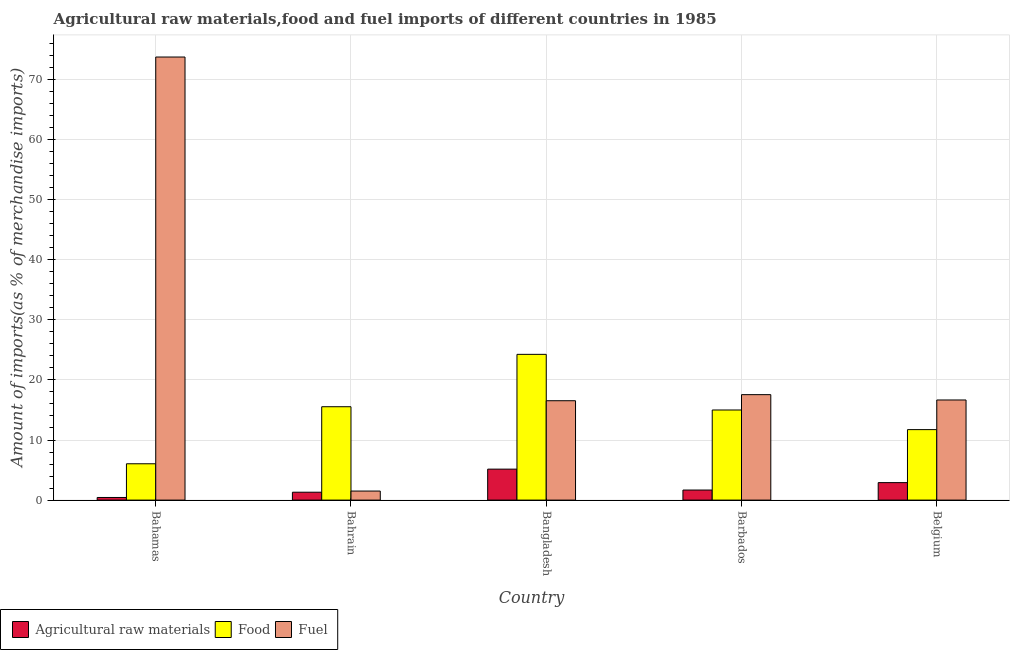Are the number of bars on each tick of the X-axis equal?
Provide a short and direct response. Yes. How many bars are there on the 2nd tick from the left?
Offer a terse response. 3. What is the percentage of food imports in Belgium?
Offer a very short reply. 11.73. Across all countries, what is the maximum percentage of fuel imports?
Your answer should be very brief. 73.72. Across all countries, what is the minimum percentage of raw materials imports?
Provide a succinct answer. 0.44. In which country was the percentage of food imports maximum?
Give a very brief answer. Bangladesh. In which country was the percentage of food imports minimum?
Offer a very short reply. Bahamas. What is the total percentage of fuel imports in the graph?
Offer a terse response. 125.97. What is the difference between the percentage of fuel imports in Bahamas and that in Belgium?
Ensure brevity in your answer.  57.06. What is the difference between the percentage of fuel imports in Bahamas and the percentage of food imports in Belgium?
Offer a very short reply. 61.99. What is the average percentage of fuel imports per country?
Your answer should be compact. 25.19. What is the difference between the percentage of food imports and percentage of fuel imports in Bahamas?
Provide a short and direct response. -67.68. What is the ratio of the percentage of fuel imports in Bahrain to that in Belgium?
Keep it short and to the point. 0.09. Is the difference between the percentage of food imports in Bahrain and Barbados greater than the difference between the percentage of raw materials imports in Bahrain and Barbados?
Your answer should be very brief. Yes. What is the difference between the highest and the second highest percentage of raw materials imports?
Give a very brief answer. 2.24. What is the difference between the highest and the lowest percentage of food imports?
Make the answer very short. 18.21. In how many countries, is the percentage of food imports greater than the average percentage of food imports taken over all countries?
Give a very brief answer. 3. Is the sum of the percentage of raw materials imports in Bahamas and Belgium greater than the maximum percentage of fuel imports across all countries?
Your response must be concise. No. What does the 2nd bar from the left in Bahrain represents?
Offer a very short reply. Food. What does the 3rd bar from the right in Bahamas represents?
Keep it short and to the point. Agricultural raw materials. Are all the bars in the graph horizontal?
Make the answer very short. No. How many countries are there in the graph?
Your answer should be very brief. 5. Does the graph contain any zero values?
Make the answer very short. No. Does the graph contain grids?
Provide a succinct answer. Yes. How are the legend labels stacked?
Give a very brief answer. Horizontal. What is the title of the graph?
Provide a succinct answer. Agricultural raw materials,food and fuel imports of different countries in 1985. What is the label or title of the X-axis?
Offer a very short reply. Country. What is the label or title of the Y-axis?
Make the answer very short. Amount of imports(as % of merchandise imports). What is the Amount of imports(as % of merchandise imports) of Agricultural raw materials in Bahamas?
Give a very brief answer. 0.44. What is the Amount of imports(as % of merchandise imports) of Food in Bahamas?
Your answer should be compact. 6.05. What is the Amount of imports(as % of merchandise imports) of Fuel in Bahamas?
Your response must be concise. 73.72. What is the Amount of imports(as % of merchandise imports) in Agricultural raw materials in Bahrain?
Offer a terse response. 1.31. What is the Amount of imports(as % of merchandise imports) of Food in Bahrain?
Your answer should be compact. 15.54. What is the Amount of imports(as % of merchandise imports) in Fuel in Bahrain?
Offer a very short reply. 1.51. What is the Amount of imports(as % of merchandise imports) in Agricultural raw materials in Bangladesh?
Your answer should be very brief. 5.15. What is the Amount of imports(as % of merchandise imports) in Food in Bangladesh?
Your answer should be very brief. 24.25. What is the Amount of imports(as % of merchandise imports) of Fuel in Bangladesh?
Make the answer very short. 16.54. What is the Amount of imports(as % of merchandise imports) in Agricultural raw materials in Barbados?
Offer a very short reply. 1.67. What is the Amount of imports(as % of merchandise imports) in Food in Barbados?
Make the answer very short. 14.99. What is the Amount of imports(as % of merchandise imports) in Fuel in Barbados?
Provide a short and direct response. 17.55. What is the Amount of imports(as % of merchandise imports) of Agricultural raw materials in Belgium?
Your answer should be compact. 2.91. What is the Amount of imports(as % of merchandise imports) of Food in Belgium?
Keep it short and to the point. 11.73. What is the Amount of imports(as % of merchandise imports) of Fuel in Belgium?
Your answer should be very brief. 16.66. Across all countries, what is the maximum Amount of imports(as % of merchandise imports) of Agricultural raw materials?
Ensure brevity in your answer.  5.15. Across all countries, what is the maximum Amount of imports(as % of merchandise imports) of Food?
Keep it short and to the point. 24.25. Across all countries, what is the maximum Amount of imports(as % of merchandise imports) of Fuel?
Keep it short and to the point. 73.72. Across all countries, what is the minimum Amount of imports(as % of merchandise imports) of Agricultural raw materials?
Provide a short and direct response. 0.44. Across all countries, what is the minimum Amount of imports(as % of merchandise imports) of Food?
Offer a terse response. 6.05. Across all countries, what is the minimum Amount of imports(as % of merchandise imports) in Fuel?
Your answer should be very brief. 1.51. What is the total Amount of imports(as % of merchandise imports) in Agricultural raw materials in the graph?
Make the answer very short. 11.49. What is the total Amount of imports(as % of merchandise imports) in Food in the graph?
Your answer should be very brief. 72.56. What is the total Amount of imports(as % of merchandise imports) of Fuel in the graph?
Make the answer very short. 125.97. What is the difference between the Amount of imports(as % of merchandise imports) of Agricultural raw materials in Bahamas and that in Bahrain?
Offer a terse response. -0.88. What is the difference between the Amount of imports(as % of merchandise imports) in Food in Bahamas and that in Bahrain?
Make the answer very short. -9.49. What is the difference between the Amount of imports(as % of merchandise imports) of Fuel in Bahamas and that in Bahrain?
Make the answer very short. 72.22. What is the difference between the Amount of imports(as % of merchandise imports) of Agricultural raw materials in Bahamas and that in Bangladesh?
Make the answer very short. -4.72. What is the difference between the Amount of imports(as % of merchandise imports) in Food in Bahamas and that in Bangladesh?
Offer a terse response. -18.21. What is the difference between the Amount of imports(as % of merchandise imports) in Fuel in Bahamas and that in Bangladesh?
Give a very brief answer. 57.19. What is the difference between the Amount of imports(as % of merchandise imports) in Agricultural raw materials in Bahamas and that in Barbados?
Offer a terse response. -1.24. What is the difference between the Amount of imports(as % of merchandise imports) of Food in Bahamas and that in Barbados?
Give a very brief answer. -8.95. What is the difference between the Amount of imports(as % of merchandise imports) in Fuel in Bahamas and that in Barbados?
Offer a terse response. 56.18. What is the difference between the Amount of imports(as % of merchandise imports) in Agricultural raw materials in Bahamas and that in Belgium?
Your answer should be very brief. -2.47. What is the difference between the Amount of imports(as % of merchandise imports) in Food in Bahamas and that in Belgium?
Offer a terse response. -5.68. What is the difference between the Amount of imports(as % of merchandise imports) in Fuel in Bahamas and that in Belgium?
Your answer should be very brief. 57.06. What is the difference between the Amount of imports(as % of merchandise imports) in Agricultural raw materials in Bahrain and that in Bangladesh?
Offer a terse response. -3.84. What is the difference between the Amount of imports(as % of merchandise imports) of Food in Bahrain and that in Bangladesh?
Your response must be concise. -8.72. What is the difference between the Amount of imports(as % of merchandise imports) of Fuel in Bahrain and that in Bangladesh?
Your response must be concise. -15.03. What is the difference between the Amount of imports(as % of merchandise imports) in Agricultural raw materials in Bahrain and that in Barbados?
Your response must be concise. -0.36. What is the difference between the Amount of imports(as % of merchandise imports) of Food in Bahrain and that in Barbados?
Make the answer very short. 0.54. What is the difference between the Amount of imports(as % of merchandise imports) in Fuel in Bahrain and that in Barbados?
Your response must be concise. -16.04. What is the difference between the Amount of imports(as % of merchandise imports) of Agricultural raw materials in Bahrain and that in Belgium?
Keep it short and to the point. -1.6. What is the difference between the Amount of imports(as % of merchandise imports) of Food in Bahrain and that in Belgium?
Offer a very short reply. 3.81. What is the difference between the Amount of imports(as % of merchandise imports) of Fuel in Bahrain and that in Belgium?
Your response must be concise. -15.15. What is the difference between the Amount of imports(as % of merchandise imports) in Agricultural raw materials in Bangladesh and that in Barbados?
Your answer should be compact. 3.48. What is the difference between the Amount of imports(as % of merchandise imports) of Food in Bangladesh and that in Barbados?
Your answer should be compact. 9.26. What is the difference between the Amount of imports(as % of merchandise imports) of Fuel in Bangladesh and that in Barbados?
Provide a succinct answer. -1.01. What is the difference between the Amount of imports(as % of merchandise imports) in Agricultural raw materials in Bangladesh and that in Belgium?
Provide a succinct answer. 2.24. What is the difference between the Amount of imports(as % of merchandise imports) in Food in Bangladesh and that in Belgium?
Make the answer very short. 12.52. What is the difference between the Amount of imports(as % of merchandise imports) in Fuel in Bangladesh and that in Belgium?
Provide a short and direct response. -0.13. What is the difference between the Amount of imports(as % of merchandise imports) of Agricultural raw materials in Barbados and that in Belgium?
Provide a succinct answer. -1.24. What is the difference between the Amount of imports(as % of merchandise imports) of Food in Barbados and that in Belgium?
Offer a very short reply. 3.26. What is the difference between the Amount of imports(as % of merchandise imports) of Fuel in Barbados and that in Belgium?
Your answer should be compact. 0.89. What is the difference between the Amount of imports(as % of merchandise imports) in Agricultural raw materials in Bahamas and the Amount of imports(as % of merchandise imports) in Food in Bahrain?
Your response must be concise. -15.1. What is the difference between the Amount of imports(as % of merchandise imports) of Agricultural raw materials in Bahamas and the Amount of imports(as % of merchandise imports) of Fuel in Bahrain?
Offer a very short reply. -1.07. What is the difference between the Amount of imports(as % of merchandise imports) of Food in Bahamas and the Amount of imports(as % of merchandise imports) of Fuel in Bahrain?
Offer a very short reply. 4.54. What is the difference between the Amount of imports(as % of merchandise imports) of Agricultural raw materials in Bahamas and the Amount of imports(as % of merchandise imports) of Food in Bangladesh?
Ensure brevity in your answer.  -23.82. What is the difference between the Amount of imports(as % of merchandise imports) of Agricultural raw materials in Bahamas and the Amount of imports(as % of merchandise imports) of Fuel in Bangladesh?
Your response must be concise. -16.1. What is the difference between the Amount of imports(as % of merchandise imports) in Food in Bahamas and the Amount of imports(as % of merchandise imports) in Fuel in Bangladesh?
Give a very brief answer. -10.49. What is the difference between the Amount of imports(as % of merchandise imports) in Agricultural raw materials in Bahamas and the Amount of imports(as % of merchandise imports) in Food in Barbados?
Give a very brief answer. -14.56. What is the difference between the Amount of imports(as % of merchandise imports) in Agricultural raw materials in Bahamas and the Amount of imports(as % of merchandise imports) in Fuel in Barbados?
Offer a terse response. -17.11. What is the difference between the Amount of imports(as % of merchandise imports) in Food in Bahamas and the Amount of imports(as % of merchandise imports) in Fuel in Barbados?
Give a very brief answer. -11.5. What is the difference between the Amount of imports(as % of merchandise imports) in Agricultural raw materials in Bahamas and the Amount of imports(as % of merchandise imports) in Food in Belgium?
Provide a short and direct response. -11.29. What is the difference between the Amount of imports(as % of merchandise imports) in Agricultural raw materials in Bahamas and the Amount of imports(as % of merchandise imports) in Fuel in Belgium?
Your response must be concise. -16.23. What is the difference between the Amount of imports(as % of merchandise imports) in Food in Bahamas and the Amount of imports(as % of merchandise imports) in Fuel in Belgium?
Ensure brevity in your answer.  -10.62. What is the difference between the Amount of imports(as % of merchandise imports) in Agricultural raw materials in Bahrain and the Amount of imports(as % of merchandise imports) in Food in Bangladesh?
Offer a very short reply. -22.94. What is the difference between the Amount of imports(as % of merchandise imports) of Agricultural raw materials in Bahrain and the Amount of imports(as % of merchandise imports) of Fuel in Bangladesh?
Offer a very short reply. -15.22. What is the difference between the Amount of imports(as % of merchandise imports) in Food in Bahrain and the Amount of imports(as % of merchandise imports) in Fuel in Bangladesh?
Offer a terse response. -1. What is the difference between the Amount of imports(as % of merchandise imports) in Agricultural raw materials in Bahrain and the Amount of imports(as % of merchandise imports) in Food in Barbados?
Make the answer very short. -13.68. What is the difference between the Amount of imports(as % of merchandise imports) in Agricultural raw materials in Bahrain and the Amount of imports(as % of merchandise imports) in Fuel in Barbados?
Offer a very short reply. -16.23. What is the difference between the Amount of imports(as % of merchandise imports) of Food in Bahrain and the Amount of imports(as % of merchandise imports) of Fuel in Barbados?
Offer a very short reply. -2.01. What is the difference between the Amount of imports(as % of merchandise imports) in Agricultural raw materials in Bahrain and the Amount of imports(as % of merchandise imports) in Food in Belgium?
Offer a terse response. -10.42. What is the difference between the Amount of imports(as % of merchandise imports) of Agricultural raw materials in Bahrain and the Amount of imports(as % of merchandise imports) of Fuel in Belgium?
Give a very brief answer. -15.35. What is the difference between the Amount of imports(as % of merchandise imports) of Food in Bahrain and the Amount of imports(as % of merchandise imports) of Fuel in Belgium?
Your answer should be very brief. -1.12. What is the difference between the Amount of imports(as % of merchandise imports) in Agricultural raw materials in Bangladesh and the Amount of imports(as % of merchandise imports) in Food in Barbados?
Make the answer very short. -9.84. What is the difference between the Amount of imports(as % of merchandise imports) of Agricultural raw materials in Bangladesh and the Amount of imports(as % of merchandise imports) of Fuel in Barbados?
Offer a terse response. -12.39. What is the difference between the Amount of imports(as % of merchandise imports) of Food in Bangladesh and the Amount of imports(as % of merchandise imports) of Fuel in Barbados?
Keep it short and to the point. 6.71. What is the difference between the Amount of imports(as % of merchandise imports) of Agricultural raw materials in Bangladesh and the Amount of imports(as % of merchandise imports) of Food in Belgium?
Offer a very short reply. -6.58. What is the difference between the Amount of imports(as % of merchandise imports) of Agricultural raw materials in Bangladesh and the Amount of imports(as % of merchandise imports) of Fuel in Belgium?
Provide a succinct answer. -11.51. What is the difference between the Amount of imports(as % of merchandise imports) in Food in Bangladesh and the Amount of imports(as % of merchandise imports) in Fuel in Belgium?
Your answer should be very brief. 7.59. What is the difference between the Amount of imports(as % of merchandise imports) in Agricultural raw materials in Barbados and the Amount of imports(as % of merchandise imports) in Food in Belgium?
Keep it short and to the point. -10.05. What is the difference between the Amount of imports(as % of merchandise imports) of Agricultural raw materials in Barbados and the Amount of imports(as % of merchandise imports) of Fuel in Belgium?
Your response must be concise. -14.99. What is the difference between the Amount of imports(as % of merchandise imports) in Food in Barbados and the Amount of imports(as % of merchandise imports) in Fuel in Belgium?
Offer a terse response. -1.67. What is the average Amount of imports(as % of merchandise imports) in Agricultural raw materials per country?
Give a very brief answer. 2.3. What is the average Amount of imports(as % of merchandise imports) in Food per country?
Provide a short and direct response. 14.51. What is the average Amount of imports(as % of merchandise imports) in Fuel per country?
Your answer should be compact. 25.19. What is the difference between the Amount of imports(as % of merchandise imports) of Agricultural raw materials and Amount of imports(as % of merchandise imports) of Food in Bahamas?
Offer a terse response. -5.61. What is the difference between the Amount of imports(as % of merchandise imports) of Agricultural raw materials and Amount of imports(as % of merchandise imports) of Fuel in Bahamas?
Provide a short and direct response. -73.29. What is the difference between the Amount of imports(as % of merchandise imports) in Food and Amount of imports(as % of merchandise imports) in Fuel in Bahamas?
Your response must be concise. -67.68. What is the difference between the Amount of imports(as % of merchandise imports) in Agricultural raw materials and Amount of imports(as % of merchandise imports) in Food in Bahrain?
Provide a succinct answer. -14.22. What is the difference between the Amount of imports(as % of merchandise imports) in Agricultural raw materials and Amount of imports(as % of merchandise imports) in Fuel in Bahrain?
Give a very brief answer. -0.19. What is the difference between the Amount of imports(as % of merchandise imports) of Food and Amount of imports(as % of merchandise imports) of Fuel in Bahrain?
Offer a terse response. 14.03. What is the difference between the Amount of imports(as % of merchandise imports) in Agricultural raw materials and Amount of imports(as % of merchandise imports) in Food in Bangladesh?
Give a very brief answer. -19.1. What is the difference between the Amount of imports(as % of merchandise imports) of Agricultural raw materials and Amount of imports(as % of merchandise imports) of Fuel in Bangladesh?
Keep it short and to the point. -11.38. What is the difference between the Amount of imports(as % of merchandise imports) in Food and Amount of imports(as % of merchandise imports) in Fuel in Bangladesh?
Provide a short and direct response. 7.72. What is the difference between the Amount of imports(as % of merchandise imports) in Agricultural raw materials and Amount of imports(as % of merchandise imports) in Food in Barbados?
Offer a very short reply. -13.32. What is the difference between the Amount of imports(as % of merchandise imports) in Agricultural raw materials and Amount of imports(as % of merchandise imports) in Fuel in Barbados?
Provide a short and direct response. -15.87. What is the difference between the Amount of imports(as % of merchandise imports) in Food and Amount of imports(as % of merchandise imports) in Fuel in Barbados?
Provide a succinct answer. -2.55. What is the difference between the Amount of imports(as % of merchandise imports) of Agricultural raw materials and Amount of imports(as % of merchandise imports) of Food in Belgium?
Offer a terse response. -8.82. What is the difference between the Amount of imports(as % of merchandise imports) of Agricultural raw materials and Amount of imports(as % of merchandise imports) of Fuel in Belgium?
Make the answer very short. -13.75. What is the difference between the Amount of imports(as % of merchandise imports) in Food and Amount of imports(as % of merchandise imports) in Fuel in Belgium?
Offer a very short reply. -4.93. What is the ratio of the Amount of imports(as % of merchandise imports) in Agricultural raw materials in Bahamas to that in Bahrain?
Offer a very short reply. 0.33. What is the ratio of the Amount of imports(as % of merchandise imports) of Food in Bahamas to that in Bahrain?
Your answer should be compact. 0.39. What is the ratio of the Amount of imports(as % of merchandise imports) of Fuel in Bahamas to that in Bahrain?
Your response must be concise. 48.95. What is the ratio of the Amount of imports(as % of merchandise imports) of Agricultural raw materials in Bahamas to that in Bangladesh?
Give a very brief answer. 0.08. What is the ratio of the Amount of imports(as % of merchandise imports) of Food in Bahamas to that in Bangladesh?
Your answer should be very brief. 0.25. What is the ratio of the Amount of imports(as % of merchandise imports) of Fuel in Bahamas to that in Bangladesh?
Give a very brief answer. 4.46. What is the ratio of the Amount of imports(as % of merchandise imports) in Agricultural raw materials in Bahamas to that in Barbados?
Give a very brief answer. 0.26. What is the ratio of the Amount of imports(as % of merchandise imports) in Food in Bahamas to that in Barbados?
Keep it short and to the point. 0.4. What is the ratio of the Amount of imports(as % of merchandise imports) of Fuel in Bahamas to that in Barbados?
Offer a very short reply. 4.2. What is the ratio of the Amount of imports(as % of merchandise imports) of Agricultural raw materials in Bahamas to that in Belgium?
Offer a very short reply. 0.15. What is the ratio of the Amount of imports(as % of merchandise imports) of Food in Bahamas to that in Belgium?
Offer a terse response. 0.52. What is the ratio of the Amount of imports(as % of merchandise imports) in Fuel in Bahamas to that in Belgium?
Your response must be concise. 4.42. What is the ratio of the Amount of imports(as % of merchandise imports) in Agricultural raw materials in Bahrain to that in Bangladesh?
Offer a terse response. 0.26. What is the ratio of the Amount of imports(as % of merchandise imports) of Food in Bahrain to that in Bangladesh?
Provide a succinct answer. 0.64. What is the ratio of the Amount of imports(as % of merchandise imports) of Fuel in Bahrain to that in Bangladesh?
Make the answer very short. 0.09. What is the ratio of the Amount of imports(as % of merchandise imports) in Agricultural raw materials in Bahrain to that in Barbados?
Give a very brief answer. 0.78. What is the ratio of the Amount of imports(as % of merchandise imports) in Food in Bahrain to that in Barbados?
Ensure brevity in your answer.  1.04. What is the ratio of the Amount of imports(as % of merchandise imports) of Fuel in Bahrain to that in Barbados?
Provide a short and direct response. 0.09. What is the ratio of the Amount of imports(as % of merchandise imports) of Agricultural raw materials in Bahrain to that in Belgium?
Provide a succinct answer. 0.45. What is the ratio of the Amount of imports(as % of merchandise imports) of Food in Bahrain to that in Belgium?
Ensure brevity in your answer.  1.32. What is the ratio of the Amount of imports(as % of merchandise imports) in Fuel in Bahrain to that in Belgium?
Provide a succinct answer. 0.09. What is the ratio of the Amount of imports(as % of merchandise imports) in Agricultural raw materials in Bangladesh to that in Barbados?
Ensure brevity in your answer.  3.08. What is the ratio of the Amount of imports(as % of merchandise imports) of Food in Bangladesh to that in Barbados?
Make the answer very short. 1.62. What is the ratio of the Amount of imports(as % of merchandise imports) of Fuel in Bangladesh to that in Barbados?
Keep it short and to the point. 0.94. What is the ratio of the Amount of imports(as % of merchandise imports) in Agricultural raw materials in Bangladesh to that in Belgium?
Your answer should be compact. 1.77. What is the ratio of the Amount of imports(as % of merchandise imports) of Food in Bangladesh to that in Belgium?
Your response must be concise. 2.07. What is the ratio of the Amount of imports(as % of merchandise imports) of Agricultural raw materials in Barbados to that in Belgium?
Offer a terse response. 0.58. What is the ratio of the Amount of imports(as % of merchandise imports) in Food in Barbados to that in Belgium?
Make the answer very short. 1.28. What is the ratio of the Amount of imports(as % of merchandise imports) of Fuel in Barbados to that in Belgium?
Your answer should be very brief. 1.05. What is the difference between the highest and the second highest Amount of imports(as % of merchandise imports) in Agricultural raw materials?
Keep it short and to the point. 2.24. What is the difference between the highest and the second highest Amount of imports(as % of merchandise imports) in Food?
Make the answer very short. 8.72. What is the difference between the highest and the second highest Amount of imports(as % of merchandise imports) in Fuel?
Provide a short and direct response. 56.18. What is the difference between the highest and the lowest Amount of imports(as % of merchandise imports) of Agricultural raw materials?
Your answer should be very brief. 4.72. What is the difference between the highest and the lowest Amount of imports(as % of merchandise imports) in Food?
Give a very brief answer. 18.21. What is the difference between the highest and the lowest Amount of imports(as % of merchandise imports) of Fuel?
Ensure brevity in your answer.  72.22. 